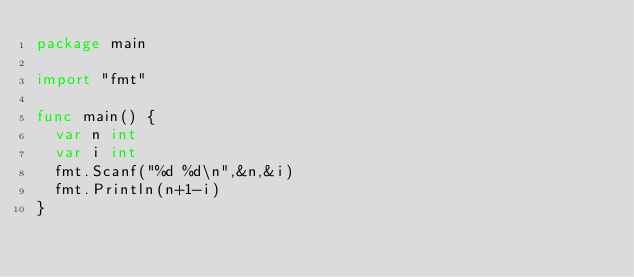Convert code to text. <code><loc_0><loc_0><loc_500><loc_500><_Go_>package main

import "fmt"

func main() {
	var n int
	var i int
	fmt.Scanf("%d %d\n",&n,&i)
	fmt.Println(n+1-i)
}</code> 